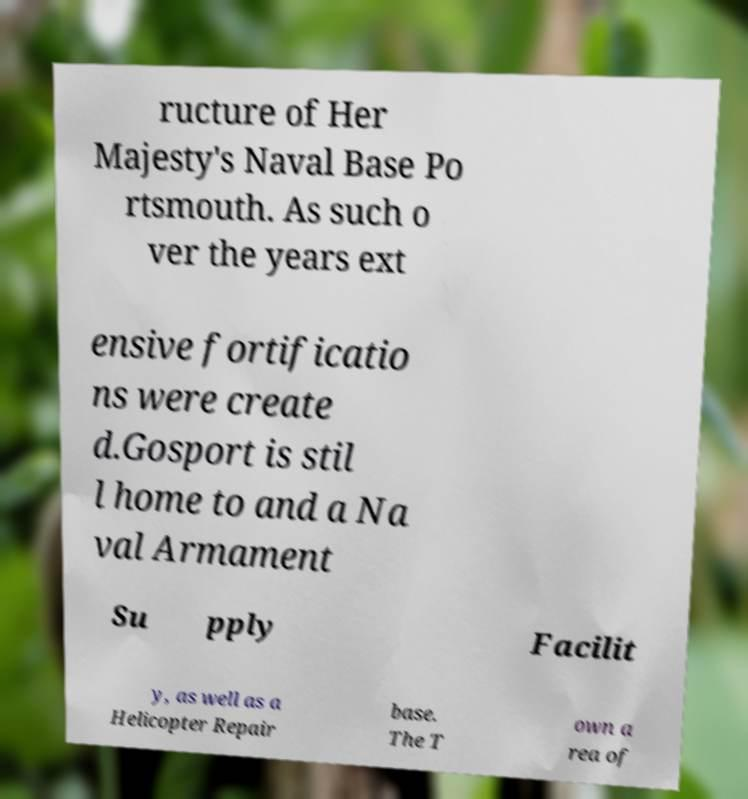Can you read and provide the text displayed in the image?This photo seems to have some interesting text. Can you extract and type it out for me? ructure of Her Majesty's Naval Base Po rtsmouth. As such o ver the years ext ensive fortificatio ns were create d.Gosport is stil l home to and a Na val Armament Su pply Facilit y, as well as a Helicopter Repair base. The T own a rea of 